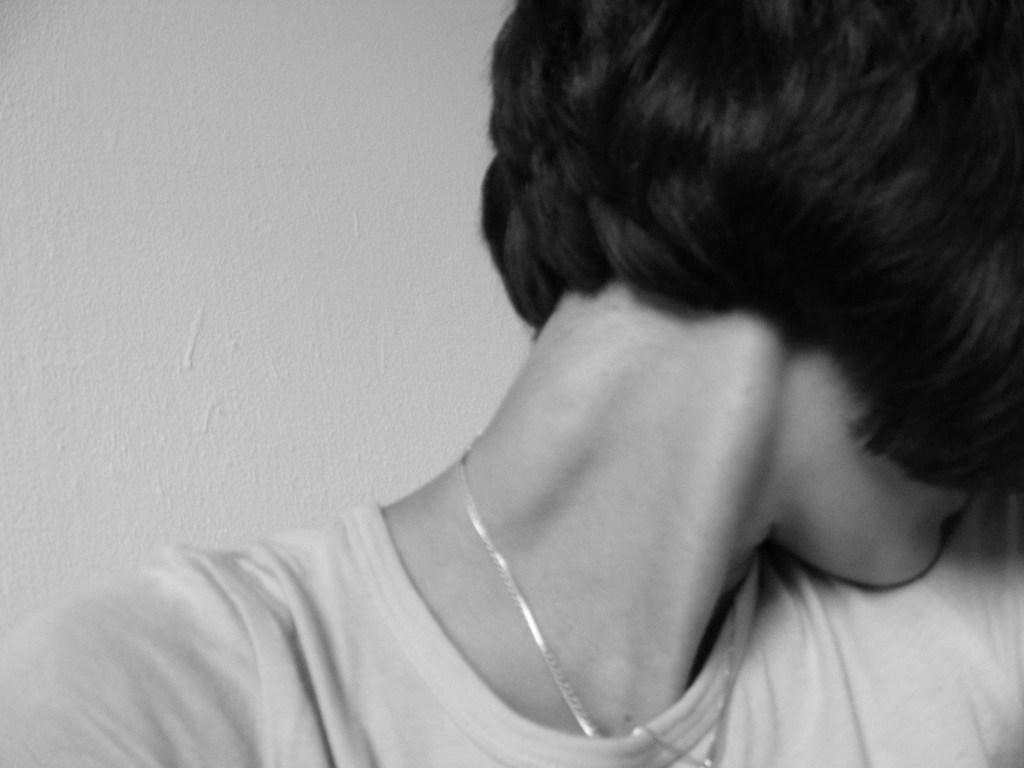How would you summarize this image in a sentence or two? In this picture there is a woman who is wearing t-shirt and locket, behind her I can see the wall. 